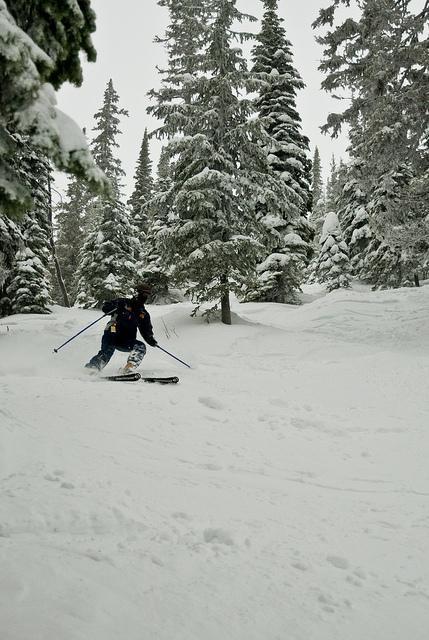How many carrots are on top of the cartoon image?
Give a very brief answer. 0. 